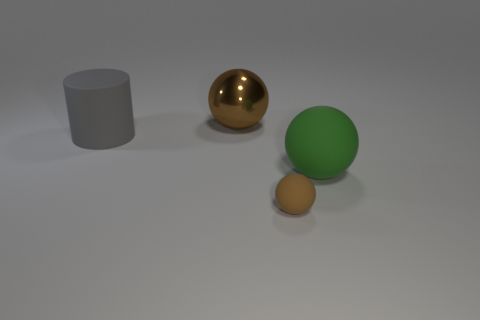What number of big blue balls have the same material as the cylinder?
Offer a very short reply. 0. Are any large brown metal spheres visible?
Your response must be concise. Yes. There is a brown thing that is to the right of the brown metal ball; what size is it?
Give a very brief answer. Small. How many tiny rubber balls are the same color as the tiny thing?
Keep it short and to the point. 0. How many blocks are tiny brown rubber things or large green matte things?
Provide a succinct answer. 0. The thing that is both on the left side of the large matte sphere and to the right of the brown shiny thing has what shape?
Make the answer very short. Sphere. Is there a green sphere that has the same size as the green object?
Offer a very short reply. No. What number of things are large rubber objects to the right of the metallic thing or large red shiny balls?
Provide a succinct answer. 1. Do the small ball and the cylinder in front of the big brown thing have the same material?
Offer a very short reply. Yes. How many other objects are there of the same shape as the gray object?
Your answer should be very brief. 0. 